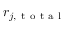<formula> <loc_0><loc_0><loc_500><loc_500>r _ { j , t o t a l }</formula> 